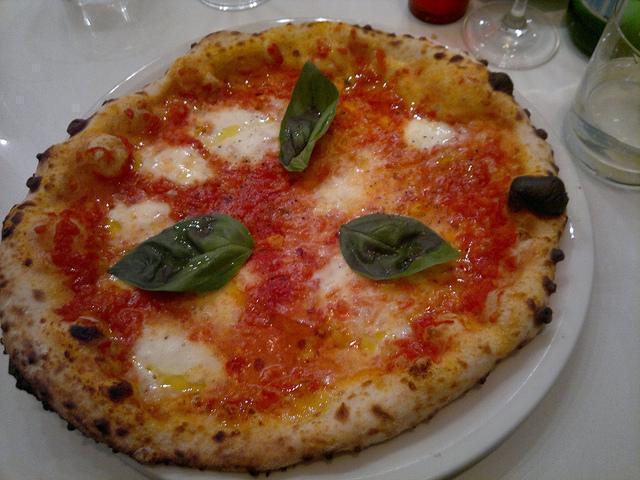Which one of these cheeses is rarely seen on this dish?
Choose the right answer from the provided options to respond to the question.
Options: Mozzarella, american, parmesan, provolone. American. 